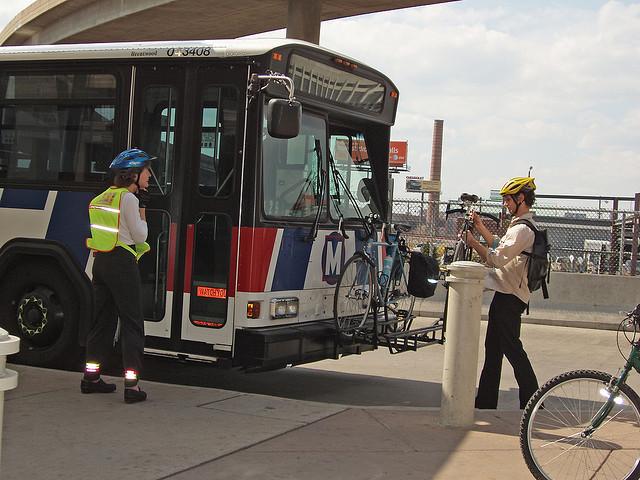Is someone handing out food?
Answer briefly. No. What color are the wheels?
Answer briefly. Black. Is that a bus?
Be succinct. Yes. Are there stars on the bus?
Keep it brief. No. What color is the bicyclist's backpack?
Give a very brief answer. Black. What is this mirror attached to?
Short answer required. Bus. Which man is the least safe in the picture?
Concise answer only. In front of bus. Is  the person getting on the bus?
Be succinct. Yes. Where is the man placing his bike?
Give a very brief answer. On bike rack. Is the sidewalk wet?
Concise answer only. No. What is the man getting on?
Concise answer only. Bus. What is the man in front of bus carrying?
Write a very short answer. Bike. Why is the woman walking in front of the vehicles?
Write a very short answer. No woman. 